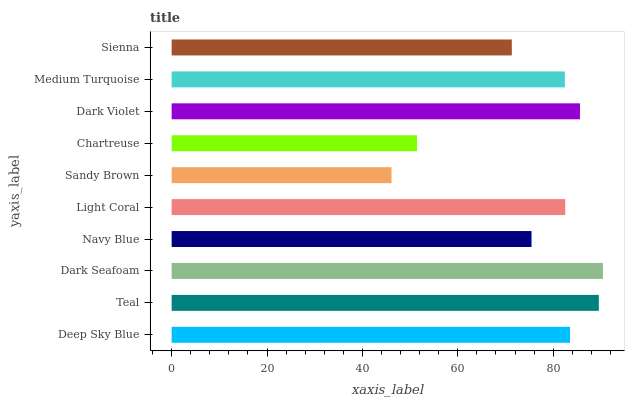Is Sandy Brown the minimum?
Answer yes or no. Yes. Is Dark Seafoam the maximum?
Answer yes or no. Yes. Is Teal the minimum?
Answer yes or no. No. Is Teal the maximum?
Answer yes or no. No. Is Teal greater than Deep Sky Blue?
Answer yes or no. Yes. Is Deep Sky Blue less than Teal?
Answer yes or no. Yes. Is Deep Sky Blue greater than Teal?
Answer yes or no. No. Is Teal less than Deep Sky Blue?
Answer yes or no. No. Is Light Coral the high median?
Answer yes or no. Yes. Is Medium Turquoise the low median?
Answer yes or no. Yes. Is Dark Seafoam the high median?
Answer yes or no. No. Is Chartreuse the low median?
Answer yes or no. No. 